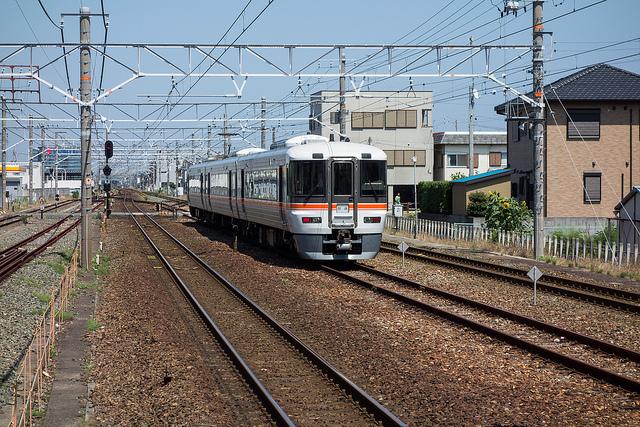Is this a passenger train?
Concise answer only. Yes. What are the colors of the train?
Write a very short answer. White and red. How are these trains powered?
Concise answer only. Electricity. 